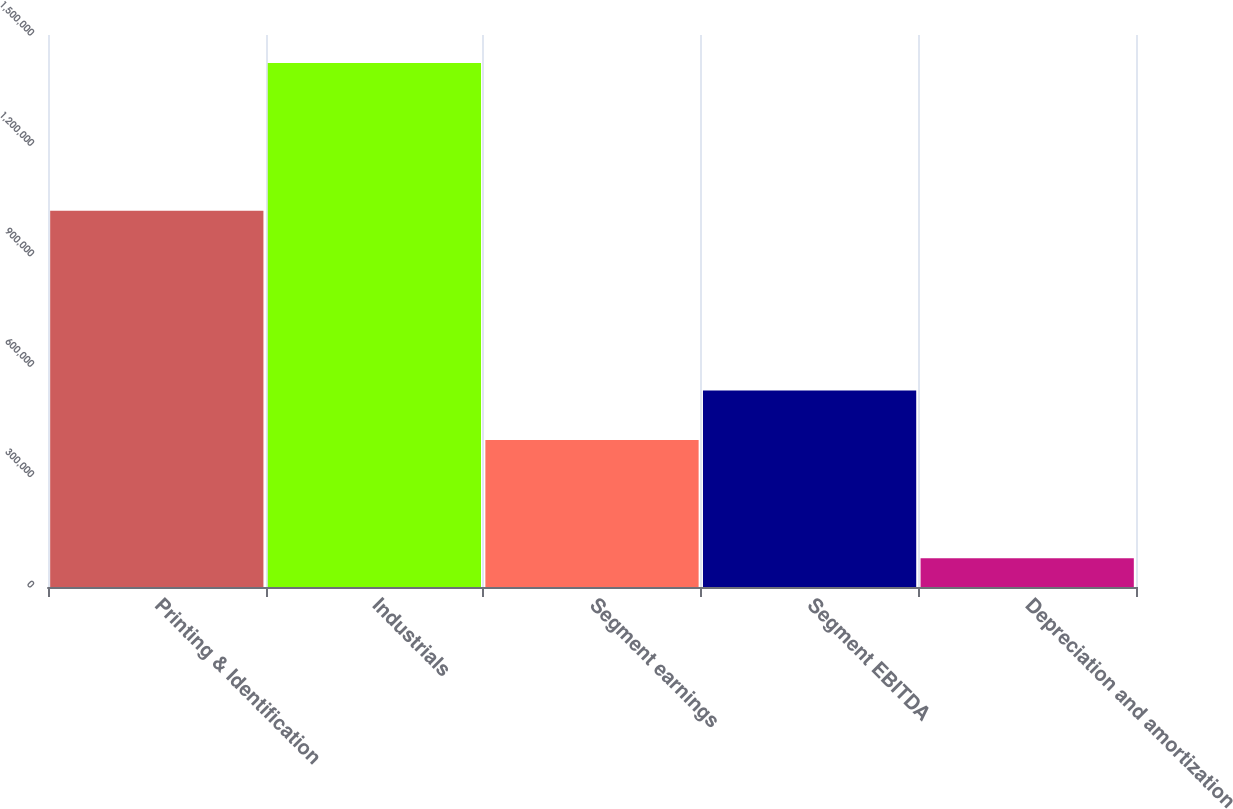<chart> <loc_0><loc_0><loc_500><loc_500><bar_chart><fcel>Printing & Identification<fcel>Industrials<fcel>Segment earnings<fcel>Segment EBITDA<fcel>Depreciation and amortization<nl><fcel>1.0225e+06<fcel>1.42416e+06<fcel>399209<fcel>533808<fcel>78173<nl></chart> 